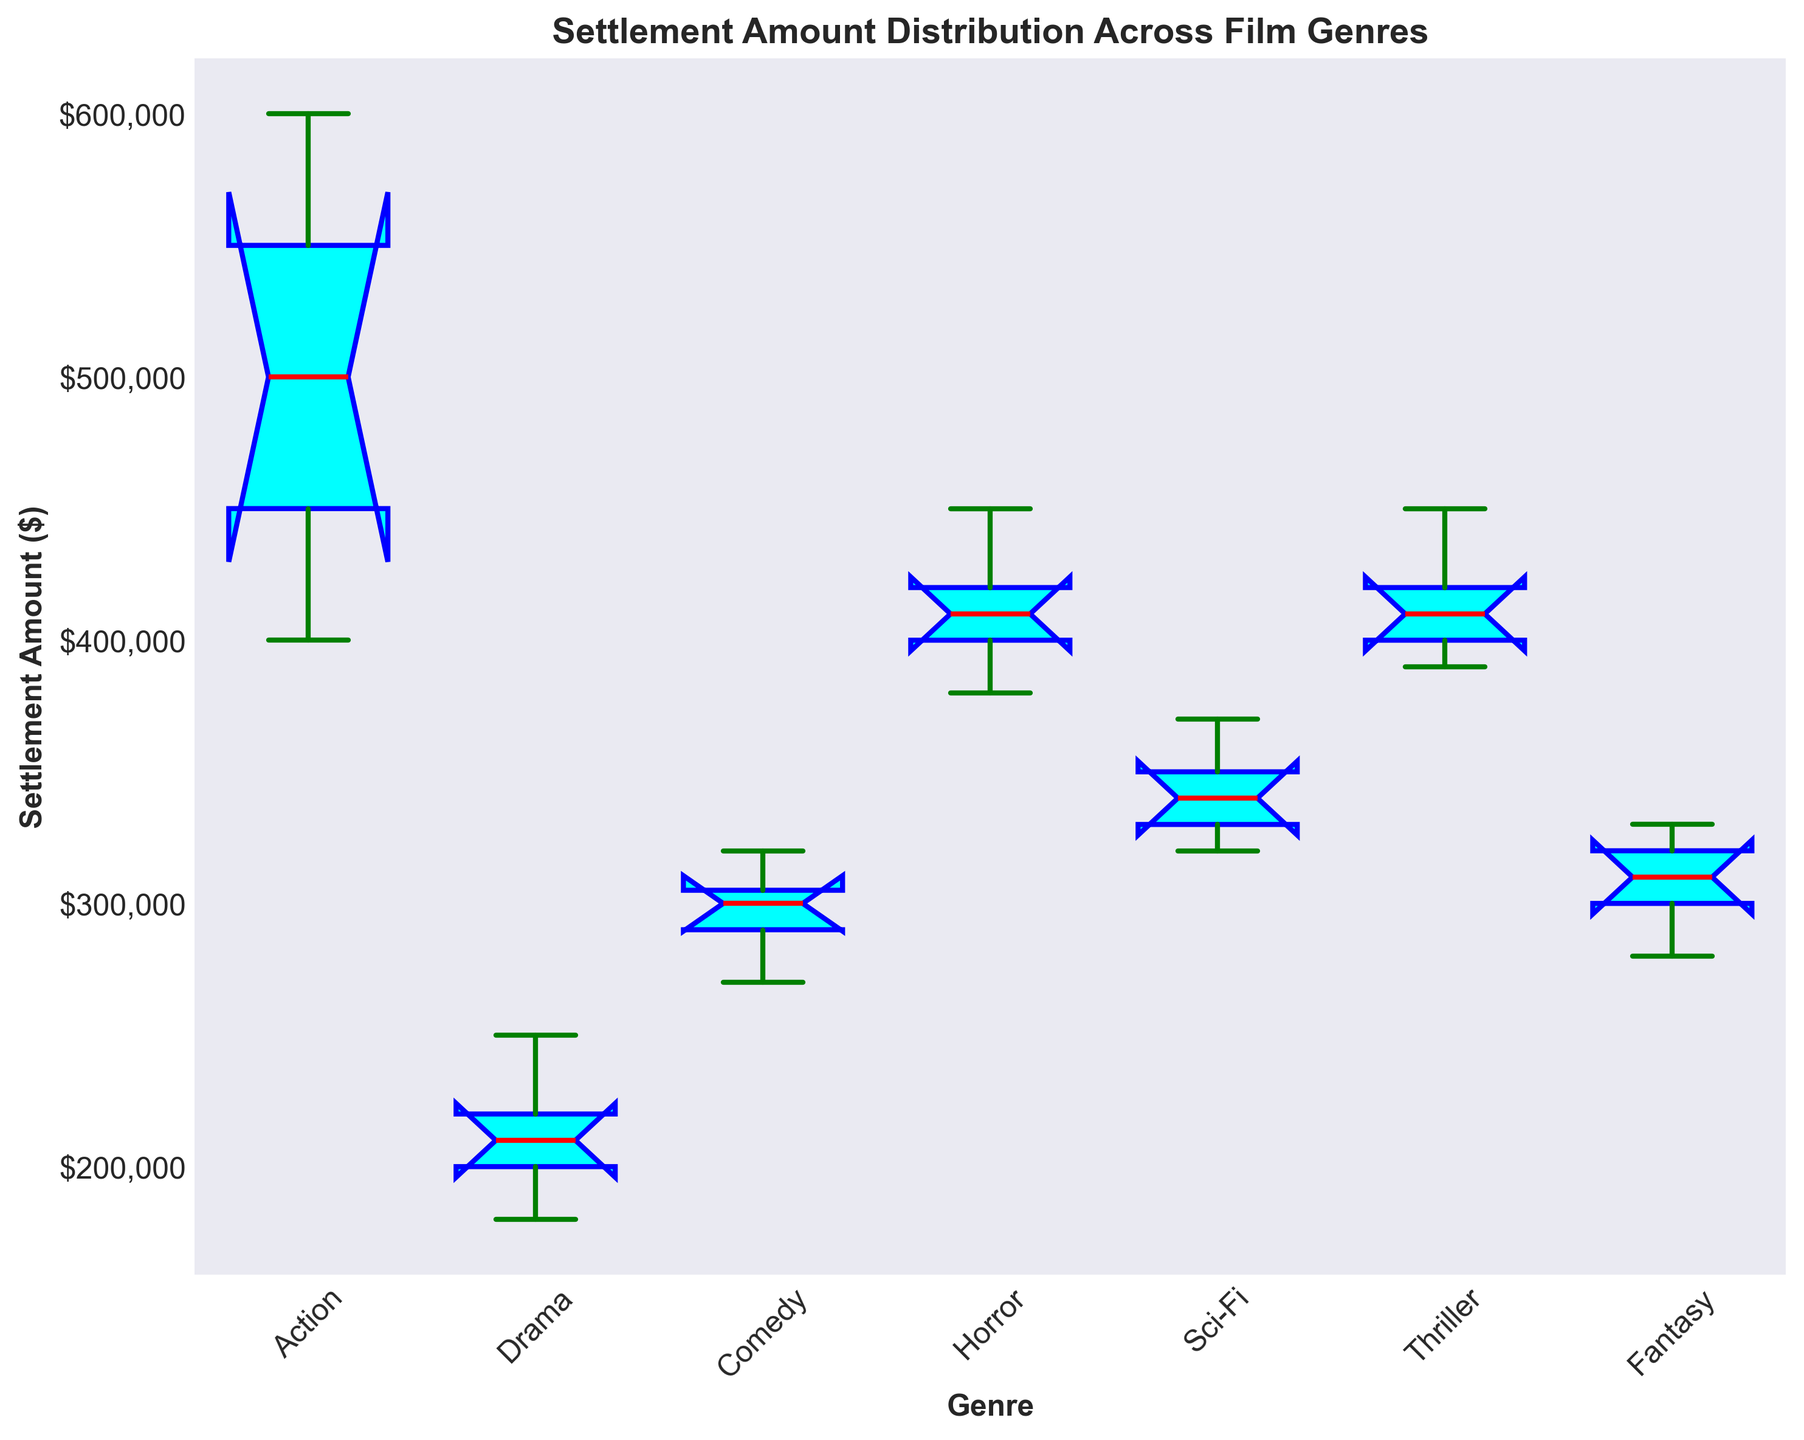Which genre has the highest median settlement amount? To determine the genre with the highest median settlement amount, look for the median line (red) in each box plot and compare their positions. The highest median line indicates the genre with the highest median settlement amount.
Answer: Action Which genre exhibits the most variability in settlement amounts? The variability in settlement amounts is depicted by the height of the interquartile range (IQR) in the box plot, which is the range between the bottom and top of the box. The genre with the tallest box has the most variability.
Answer: Action What is the median settlement amount for the Comedy genre? Locate the box plot for the Comedy genre and find the median line (red) in the box. Trace this line horizontally to the y-axis to read the median settlement amount.
Answer: $300,000 Which genre has the lowest outlier in terms of settlement amount? Outliers are represented by individual points outside the whiskers of the box plot. Identify the lowest of these points for all genres.
Answer: Drama What is the interquartile range (IQR) of the Sci-Fi genre's settlement amounts? The IQR is calculated by subtracting the value at the bottom of the Sci-Fi box (25th percentile) from the value at the top of the box (75th percentile). Read these values from the y-axis.
Answer: $20,000 Compare the median settlement amounts between Thriller and Drama genres. Which is higher? Find the median lines (red) for both Thriller and Drama genres in their box plots, and check which line is higher.
Answer: Thriller Which genre has the narrowest range of settlement amounts excluding outliers? The range is indicated by the distance between the top and bottom whiskers. Identify which genre has the shortest distance.
Answer: Fantasy Are there any genres with overlapping interquartile ranges (IQR)? Check if any box plots have overlapping boxes along the y-axis. Overlapping boxes mean the IQRs overlap.
Answer: Yes What is the approximate maximum settlement amount observed for the Horror genre, ignoring outliers? The maximum settlement amount is indicated by the top whisker of the Horror genre's box plot. Trace it horizontally to the y-axis to read the value.
Answer: $450,000 